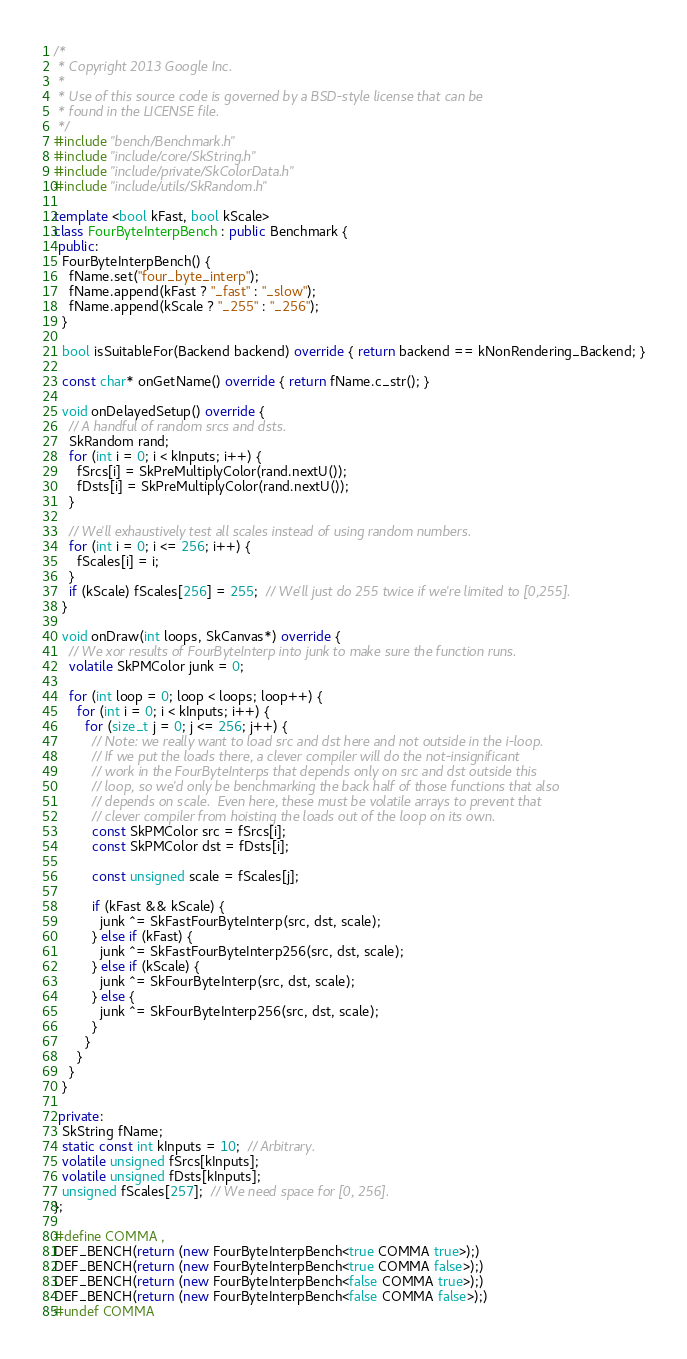Convert code to text. <code><loc_0><loc_0><loc_500><loc_500><_C++_>/*
 * Copyright 2013 Google Inc.
 *
 * Use of this source code is governed by a BSD-style license that can be
 * found in the LICENSE file.
 */
#include "bench/Benchmark.h"
#include "include/core/SkString.h"
#include "include/private/SkColorData.h"
#include "include/utils/SkRandom.h"

template <bool kFast, bool kScale>
class FourByteInterpBench : public Benchmark {
 public:
  FourByteInterpBench() {
    fName.set("four_byte_interp");
    fName.append(kFast ? "_fast" : "_slow");
    fName.append(kScale ? "_255" : "_256");
  }

  bool isSuitableFor(Backend backend) override { return backend == kNonRendering_Backend; }

  const char* onGetName() override { return fName.c_str(); }

  void onDelayedSetup() override {
    // A handful of random srcs and dsts.
    SkRandom rand;
    for (int i = 0; i < kInputs; i++) {
      fSrcs[i] = SkPreMultiplyColor(rand.nextU());
      fDsts[i] = SkPreMultiplyColor(rand.nextU());
    }

    // We'll exhaustively test all scales instead of using random numbers.
    for (int i = 0; i <= 256; i++) {
      fScales[i] = i;
    }
    if (kScale) fScales[256] = 255;  // We'll just do 255 twice if we're limited to [0,255].
  }

  void onDraw(int loops, SkCanvas*) override {
    // We xor results of FourByteInterp into junk to make sure the function runs.
    volatile SkPMColor junk = 0;

    for (int loop = 0; loop < loops; loop++) {
      for (int i = 0; i < kInputs; i++) {
        for (size_t j = 0; j <= 256; j++) {
          // Note: we really want to load src and dst here and not outside in the i-loop.
          // If we put the loads there, a clever compiler will do the not-insignificant
          // work in the FourByteInterps that depends only on src and dst outside this
          // loop, so we'd only be benchmarking the back half of those functions that also
          // depends on scale.  Even here, these must be volatile arrays to prevent that
          // clever compiler from hoisting the loads out of the loop on its own.
          const SkPMColor src = fSrcs[i];
          const SkPMColor dst = fDsts[i];

          const unsigned scale = fScales[j];

          if (kFast && kScale) {
            junk ^= SkFastFourByteInterp(src, dst, scale);
          } else if (kFast) {
            junk ^= SkFastFourByteInterp256(src, dst, scale);
          } else if (kScale) {
            junk ^= SkFourByteInterp(src, dst, scale);
          } else {
            junk ^= SkFourByteInterp256(src, dst, scale);
          }
        }
      }
    }
  }

 private:
  SkString fName;
  static const int kInputs = 10;  // Arbitrary.
  volatile unsigned fSrcs[kInputs];
  volatile unsigned fDsts[kInputs];
  unsigned fScales[257];  // We need space for [0, 256].
};

#define COMMA ,
DEF_BENCH(return (new FourByteInterpBench<true COMMA true>);)
DEF_BENCH(return (new FourByteInterpBench<true COMMA false>);)
DEF_BENCH(return (new FourByteInterpBench<false COMMA true>);)
DEF_BENCH(return (new FourByteInterpBench<false COMMA false>);)
#undef COMMA
</code> 